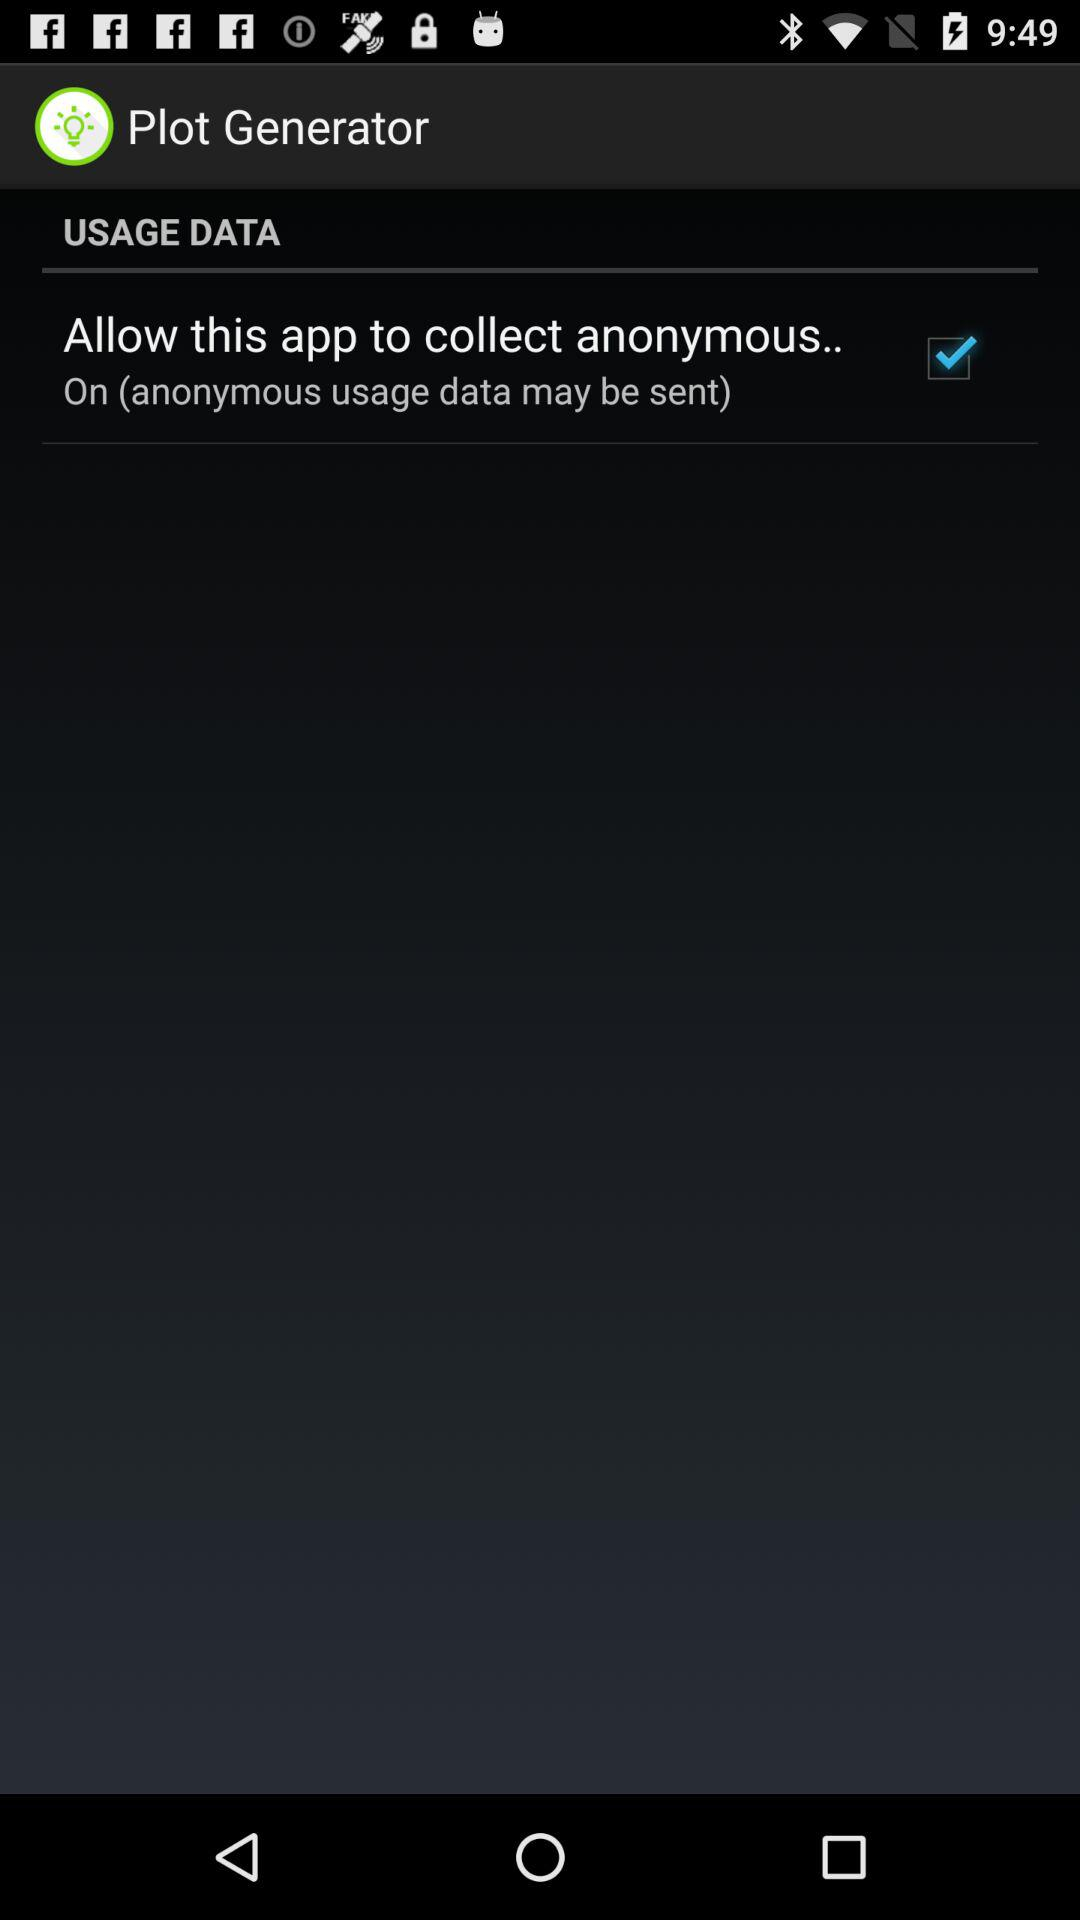What is the status of the "Allow this app to collect anonymous.."? The status is "on". 